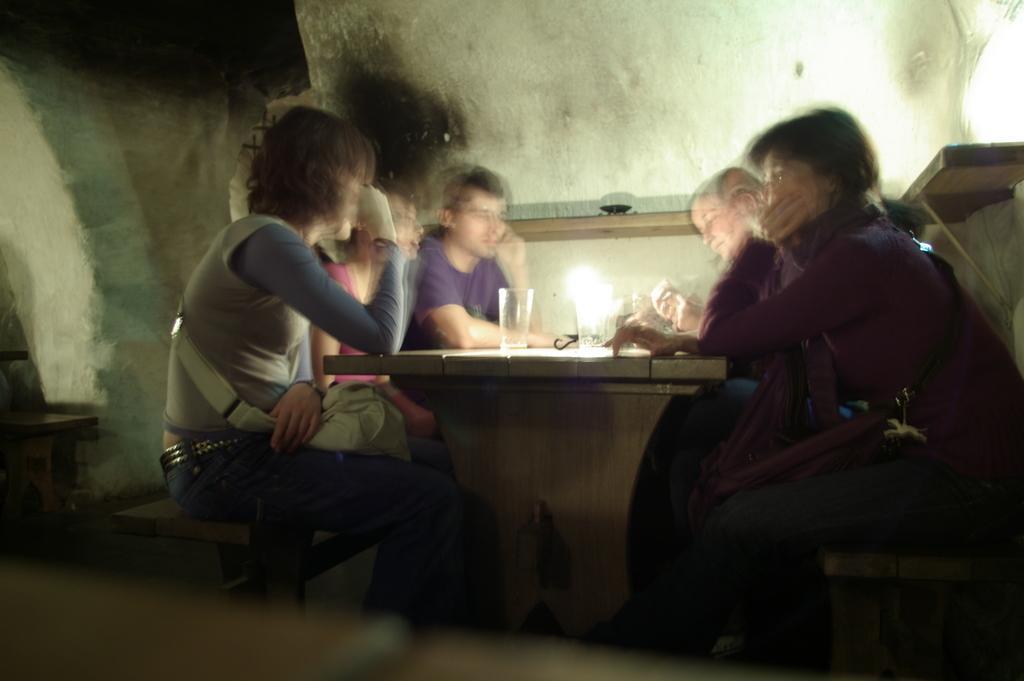Please provide a concise description of this image. In this image I can see there are the few persons sitting on the chairs and in front of them there is a table ,on the table I can see a light and glass ,back ground there is a wall. And left side I can see a staircase. 